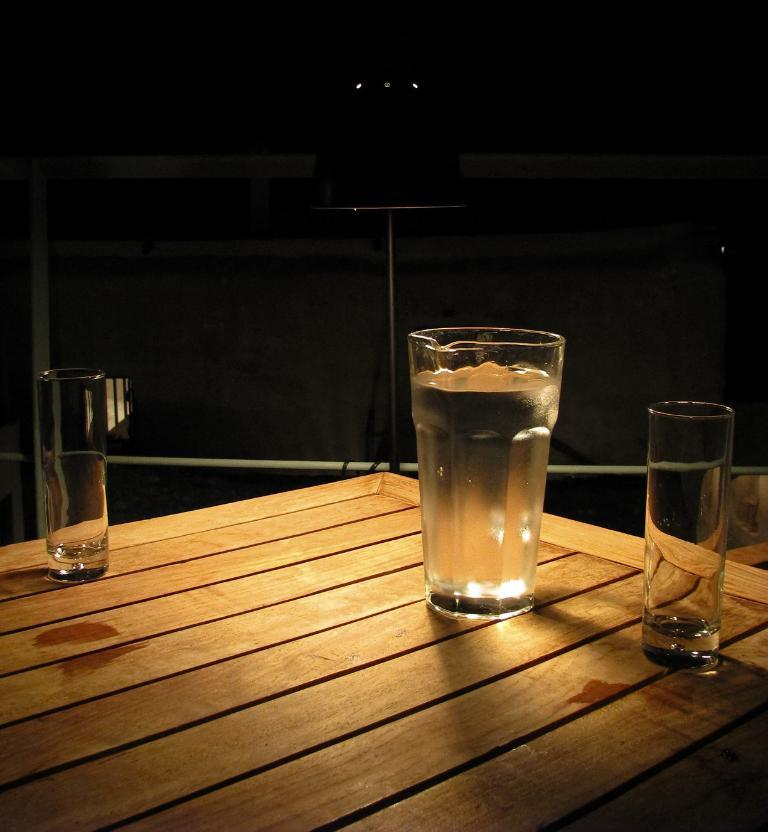What piece of furniture is present in the image? There is a table in the image. What objects are on the table? There are three glasses on the table. What type of game is being played on the table in the image? There is no game present in the image; it only shows a table with three glasses on it. 